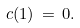<formula> <loc_0><loc_0><loc_500><loc_500>c ( 1 ) \, = \, 0 .</formula> 